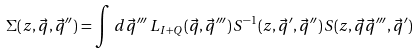Convert formula to latex. <formula><loc_0><loc_0><loc_500><loc_500>\Sigma ( z , \vec { q } , \vec { q } ^ { \prime \prime } ) = \int \, d \vec { q } ^ { \prime \prime \prime } \, L _ { I + Q } ( \vec { q } , \vec { q } ^ { \prime \prime \prime } ) \, { S } ^ { - 1 } ( z , \vec { q } ^ { \prime } , \vec { q } ^ { \prime \prime } ) \, { S } ( z , \vec { q } \vec { q } ^ { \prime \prime \prime } , \vec { q } ^ { \prime } )</formula> 